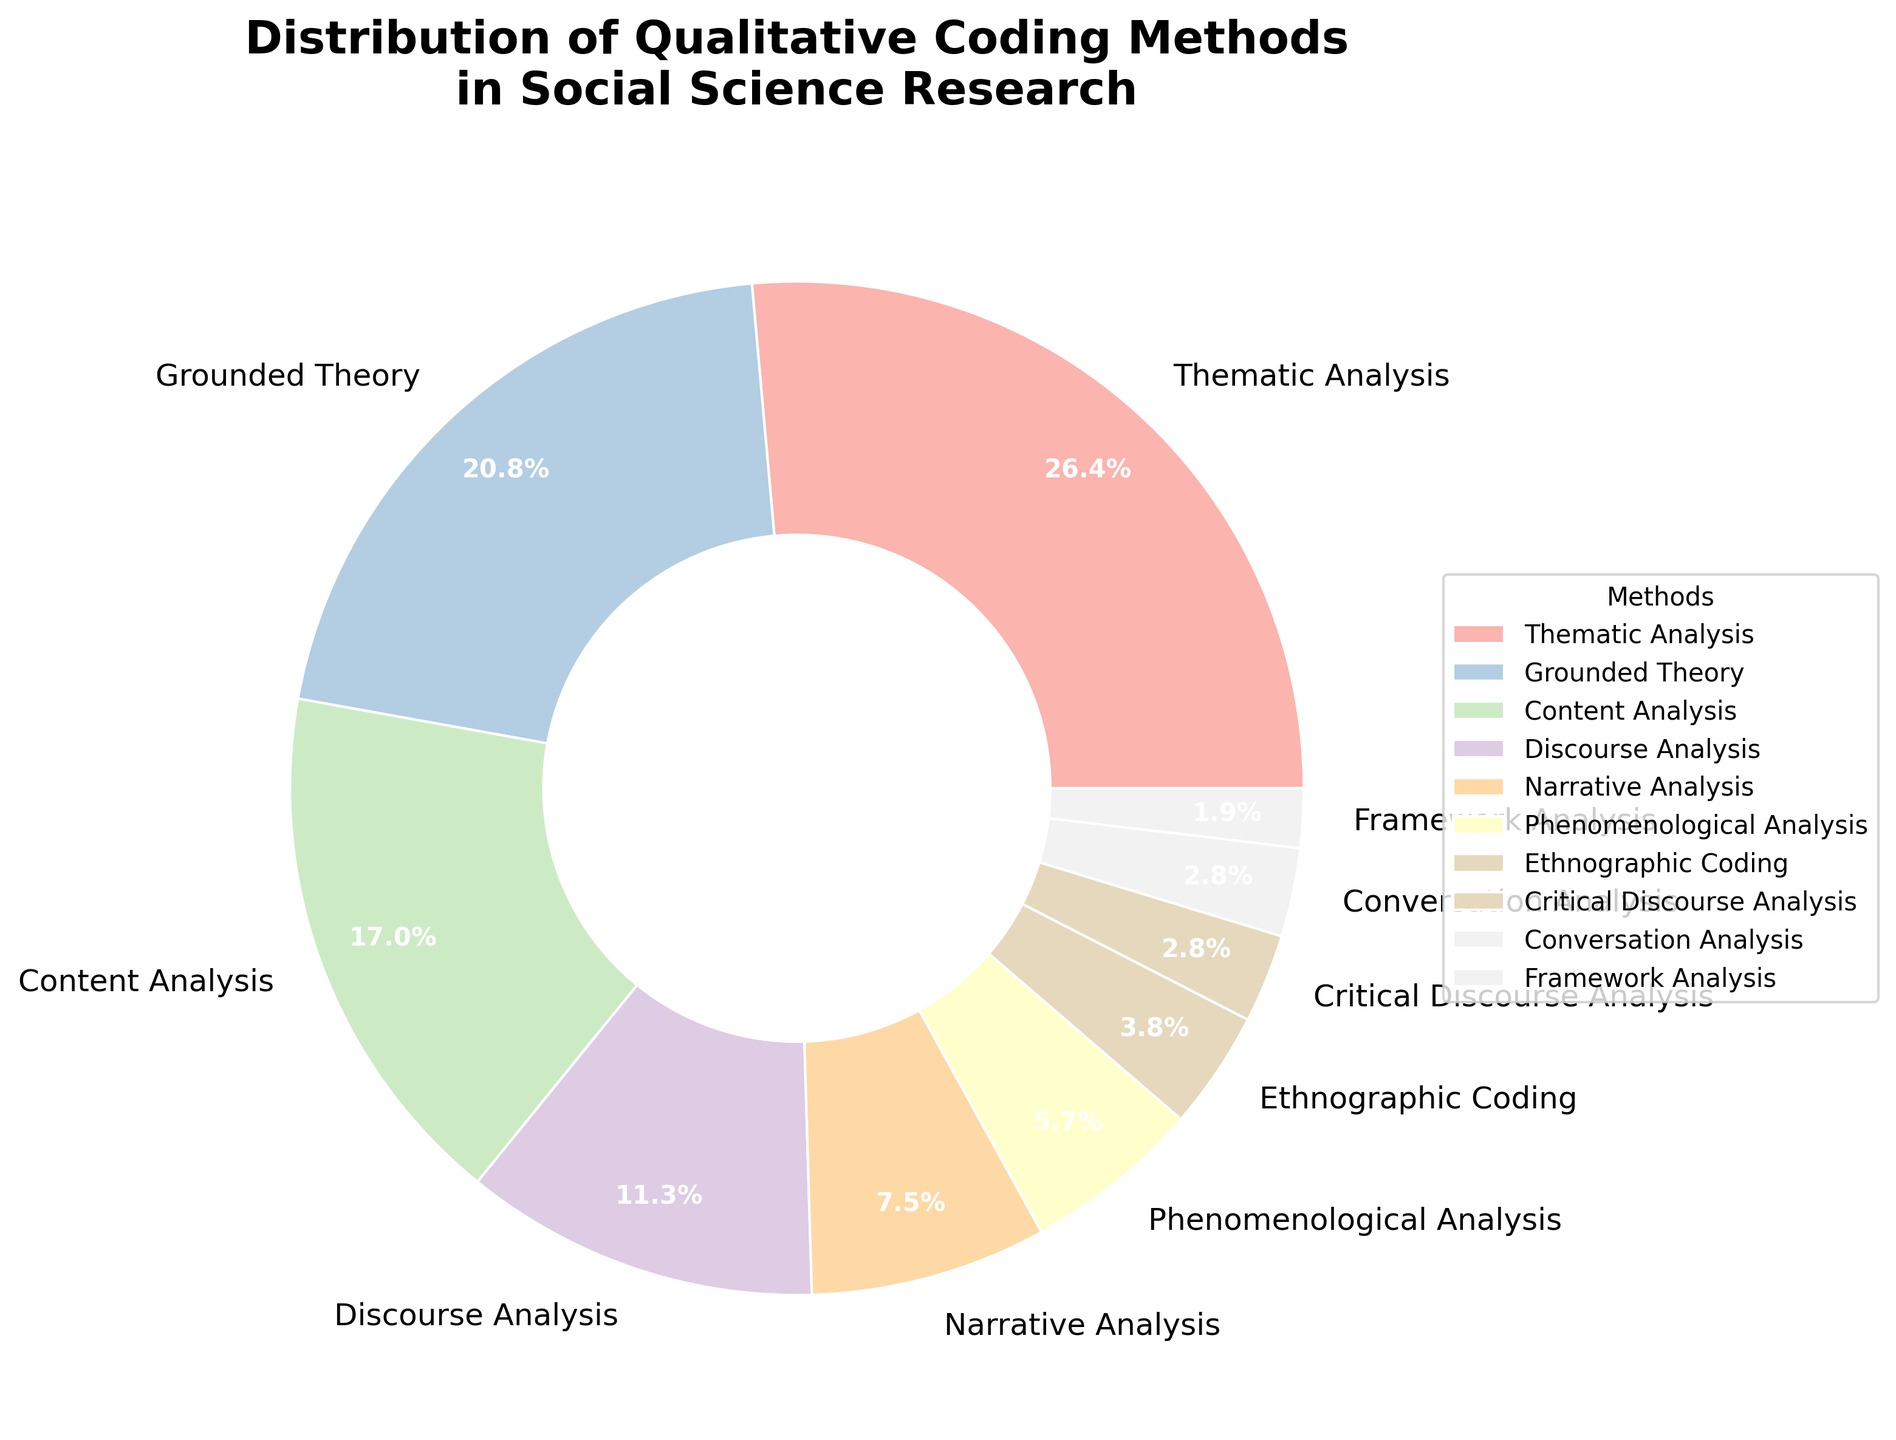What is the most frequently used qualitative coding method in social science research according to the chart? Thematic Analysis appears to have the largest wedge in the pie chart. Reading the label, it indicates 28%, which is the highest percentage among all methods.
Answer: Thematic Analysis How many methods have a percentage higher than 15%? From the pie chart, we can identify each method's slice and percentage. The methods with percentages higher than 15% are Thematic Analysis (28%), Grounded Theory (22%), and Content Analysis (18%). Therefore, there are three methods in total.
Answer: 3 What is the combined percentage of Narrative Analysis and Phenomenological Analysis? From the chart, Narrative Analysis is 8% and Phenomenological Analysis is 6%. Adding these together gives 8% + 6% = 14%.
Answer: 14% Is the percentage of Discourse Analysis greater than Conversation Analysis? Yes, it is. Discourse Analysis is 12% while Conversation Analysis is 3%. Therefore, Discourse Analysis has a higher percentage.
Answer: Yes Which method has a smaller percentage, Ethnographic Coding or Framework Analysis? Framework Analysis has a smaller percentage at 2% compared to Ethnographic Coding which is at 4%.
Answer: Framework Analysis What is the difference in percentage between Grounded Theory and Content Analysis? Grounded Theory has a percentage of 22% and Content Analysis has 18%. The difference is 22% - 18% = 4%.
Answer: 4% If you combine Ethnographic Coding, Critical Discourse Analysis, Conversation Analysis, and Framework Analysis, what is their total percentage? Ethnographic Coding is 4%, Critical Discourse Analysis is 3%, Conversation Analysis is 3%, and Framework Analysis is 2%. Adding these together yields 4% + 3% + 3% + 2% = 12%.
Answer: 12% Which coding method has a percentage closest to 10%? By visually inspecting the chart, Discourse Analysis, which is at 12%, is the closest to 10%.
Answer: Discourse Analysis Out of Discourse Analysis and Grounded Theory, which one has the smaller percentage? Discourse Analysis, with 12%, is smaller than Grounded Theory, which is 22%.
Answer: Discourse Analysis 